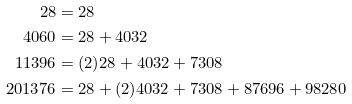Convert formula to latex. <formula><loc_0><loc_0><loc_500><loc_500>2 8 & = 2 8 \\ 4 0 6 0 & = 2 8 + 4 0 3 2 \\ 1 1 3 9 6 & = ( 2 ) 2 8 + 4 0 3 2 + 7 3 0 8 \\ 2 0 1 3 7 6 & = 2 8 + ( 2 ) 4 0 3 2 + 7 3 0 8 + 8 7 6 9 6 + 9 8 2 8 0</formula> 